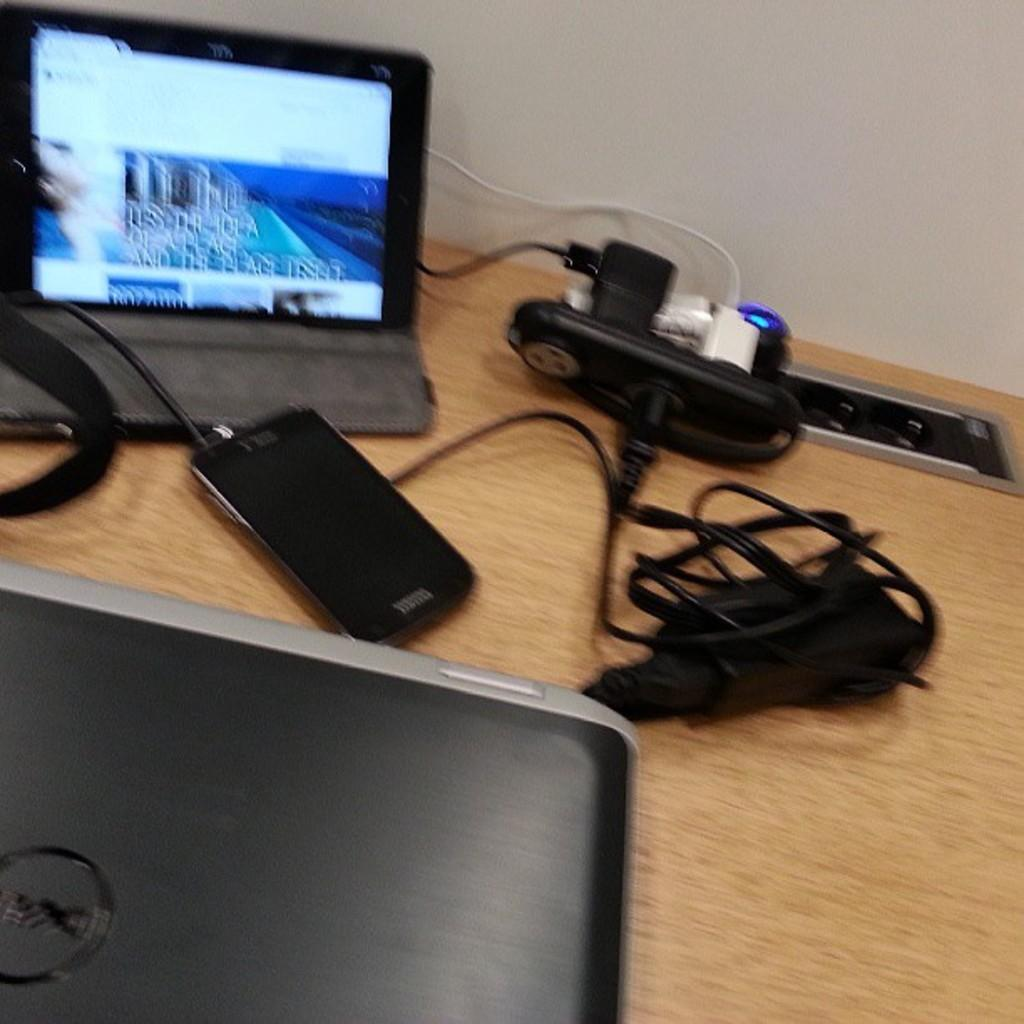What electronic device is visible in the image? There is a laptop in the image. What is the color of the laptop? The laptop is black in color. Is there any branding or logo on the laptop? Yes, there is a logo on the laptop. What other items can be seen in the image besides the laptop? There are adapters, a mobile, and wires in the image. What is the surface on which the objects are placed? The objects are placed on a wooden surface. What type of notebook is being used to write down the experience in the image? There is no notebook or experience being depicted in the image; it features a laptop, adapters, a mobile, and wires on a wooden surface. What book is being read by the person in the image? There is no person or book present in the image. 